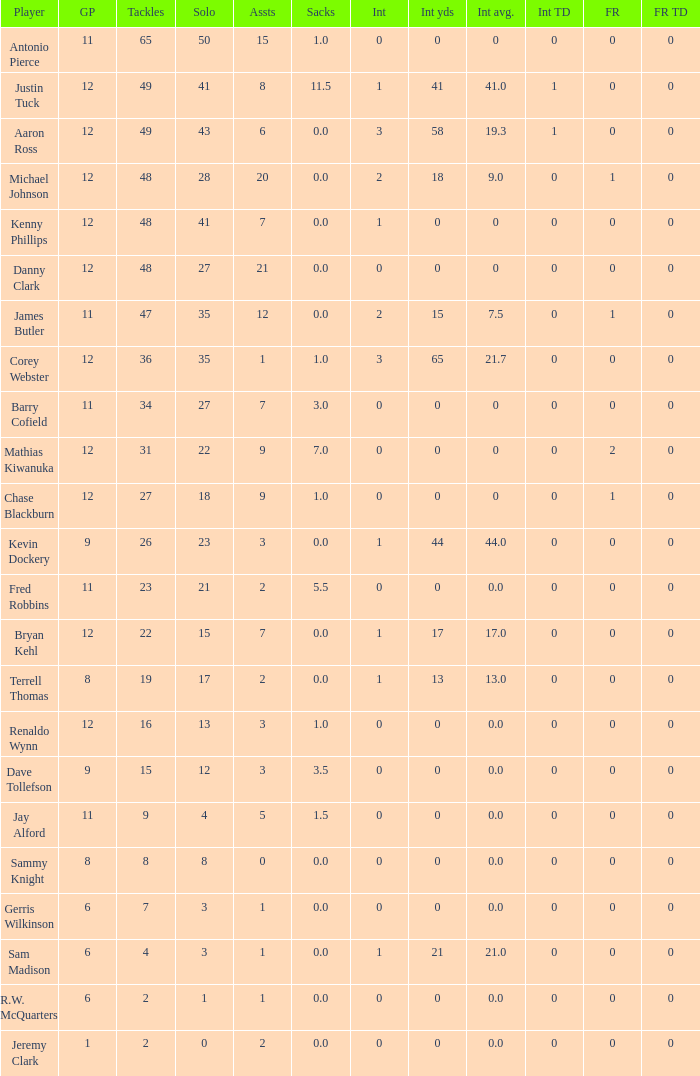Name the most tackles for 3.5 sacks 15.0. 